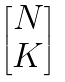<formula> <loc_0><loc_0><loc_500><loc_500>\begin{bmatrix} N \\ K \end{bmatrix}</formula> 